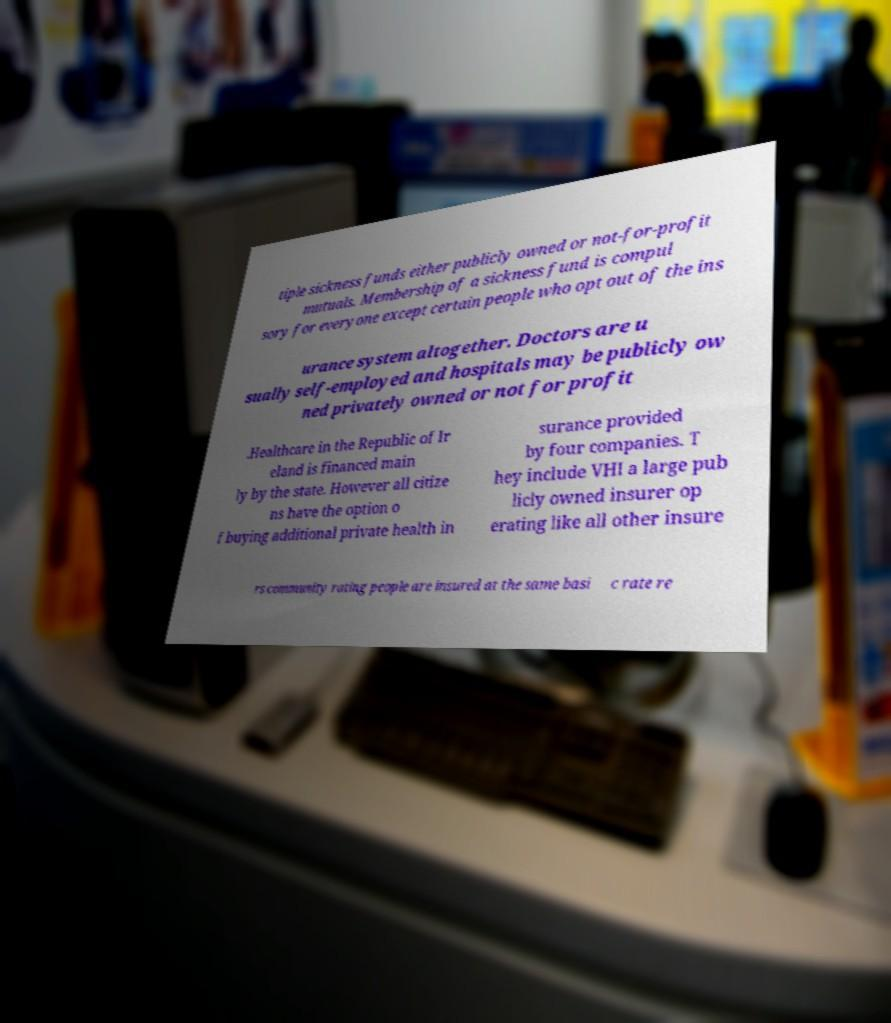There's text embedded in this image that I need extracted. Can you transcribe it verbatim? tiple sickness funds either publicly owned or not-for-profit mutuals. Membership of a sickness fund is compul sory for everyone except certain people who opt out of the ins urance system altogether. Doctors are u sually self-employed and hospitals may be publicly ow ned privately owned or not for profit .Healthcare in the Republic of Ir eland is financed main ly by the state. However all citize ns have the option o f buying additional private health in surance provided by four companies. T hey include VHI a large pub licly owned insurer op erating like all other insure rs community rating people are insured at the same basi c rate re 